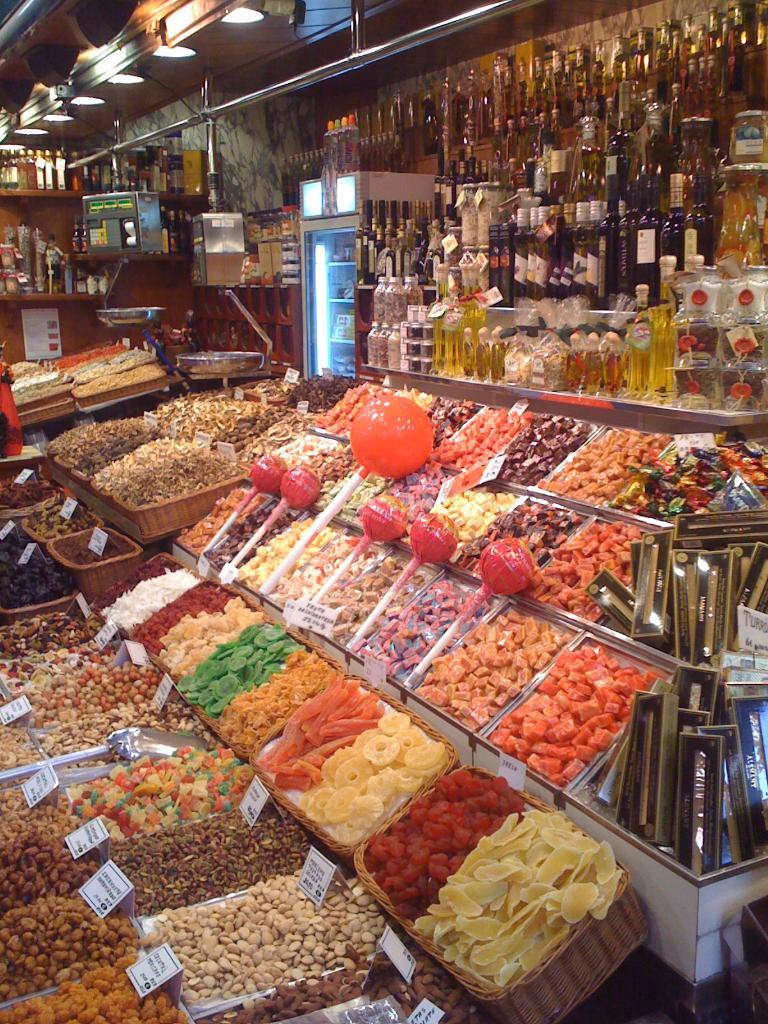What type of food items can be seen in the image? There are candies placed in trays in the image. What else can be found in the image besides candies? There are bottles in the cracks on the top of the image. What can be seen illuminating the image? There are lights visible on the top of the image. What type of nut is being ordered in the image? There is no nut or order present in the image; it only features candies, bottles, and lights. 